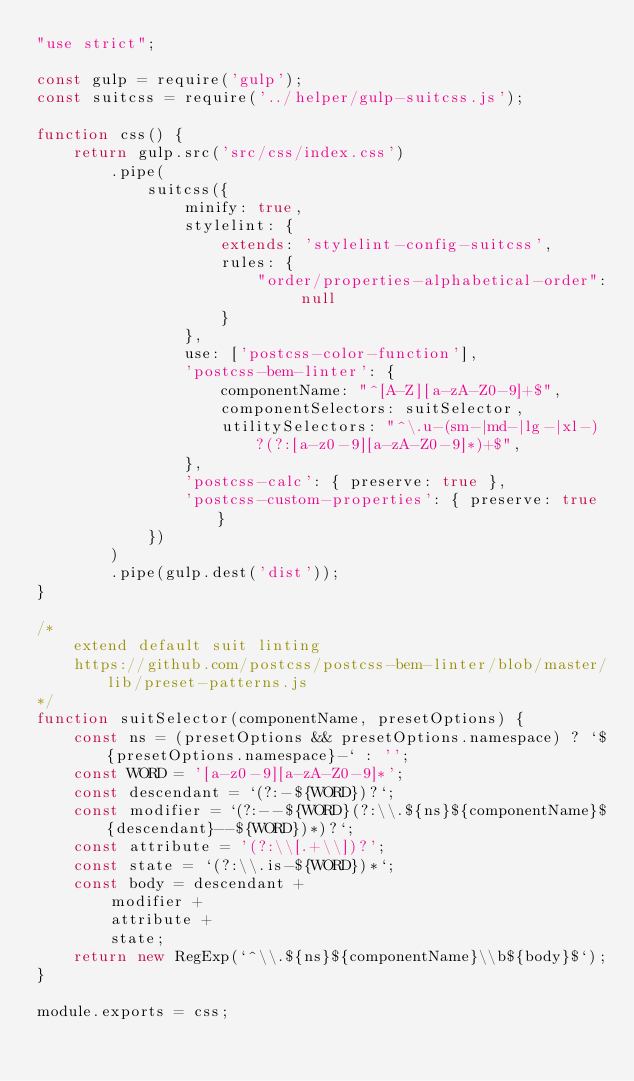Convert code to text. <code><loc_0><loc_0><loc_500><loc_500><_JavaScript_>"use strict";

const gulp = require('gulp');
const suitcss = require('../helper/gulp-suitcss.js');

function css() {
    return gulp.src('src/css/index.css')
        .pipe(
            suitcss({
                minify: true,
                stylelint: {
                    extends: 'stylelint-config-suitcss',
                    rules: {
                        "order/properties-alphabetical-order": null
                    }
                },
                use: ['postcss-color-function'],
                'postcss-bem-linter': {
                    componentName: "^[A-Z][a-zA-Z0-9]+$",
                    componentSelectors: suitSelector,
                    utilitySelectors: "^\.u-(sm-|md-|lg-|xl-)?(?:[a-z0-9][a-zA-Z0-9]*)+$",
                },
                'postcss-calc': { preserve: true },
                'postcss-custom-properties': { preserve: true }
            })
        )
        .pipe(gulp.dest('dist'));
}

/*
    extend default suit linting
    https://github.com/postcss/postcss-bem-linter/blob/master/lib/preset-patterns.js
*/
function suitSelector(componentName, presetOptions) {
    const ns = (presetOptions && presetOptions.namespace) ? `${presetOptions.namespace}-` : '';
    const WORD = '[a-z0-9][a-zA-Z0-9]*';
    const descendant = `(?:-${WORD})?`;
    const modifier = `(?:--${WORD}(?:\\.${ns}${componentName}${descendant}--${WORD})*)?`;
    const attribute = '(?:\\[.+\\])?';
    const state = `(?:\\.is-${WORD})*`;
    const body = descendant +
        modifier +
        attribute +
        state;
    return new RegExp(`^\\.${ns}${componentName}\\b${body}$`);
}

module.exports = css;</code> 